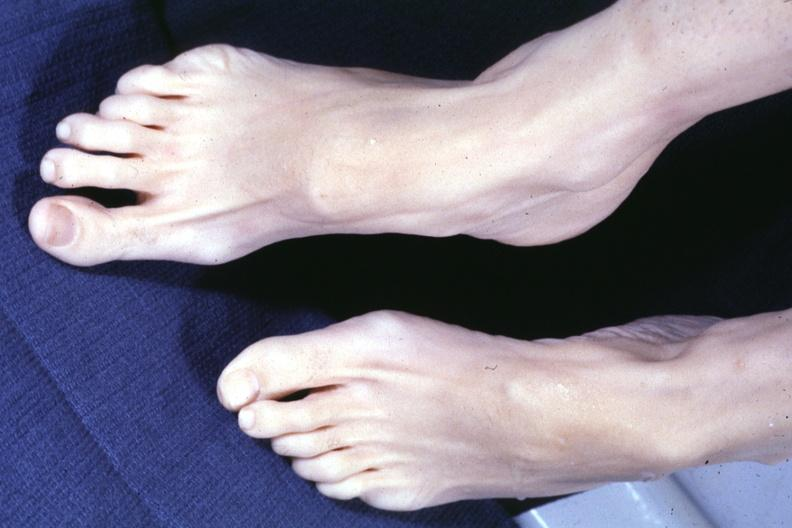what is present?
Answer the question using a single word or phrase. Arachnodactyly 